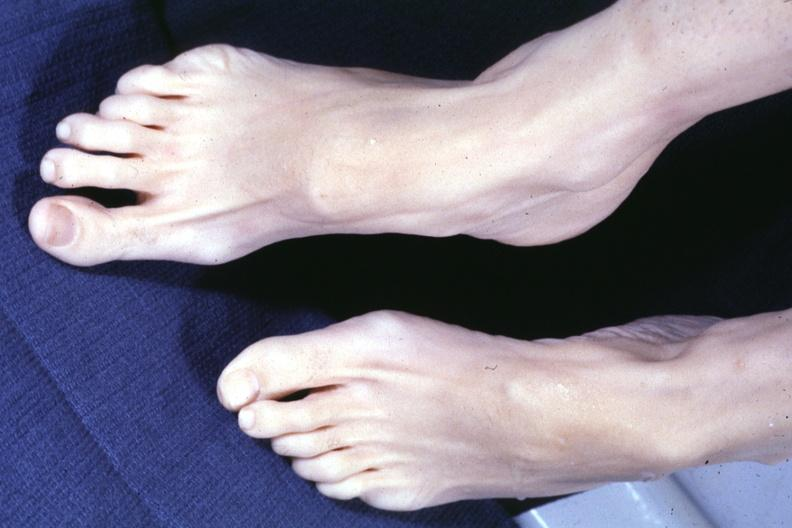what is present?
Answer the question using a single word or phrase. Arachnodactyly 